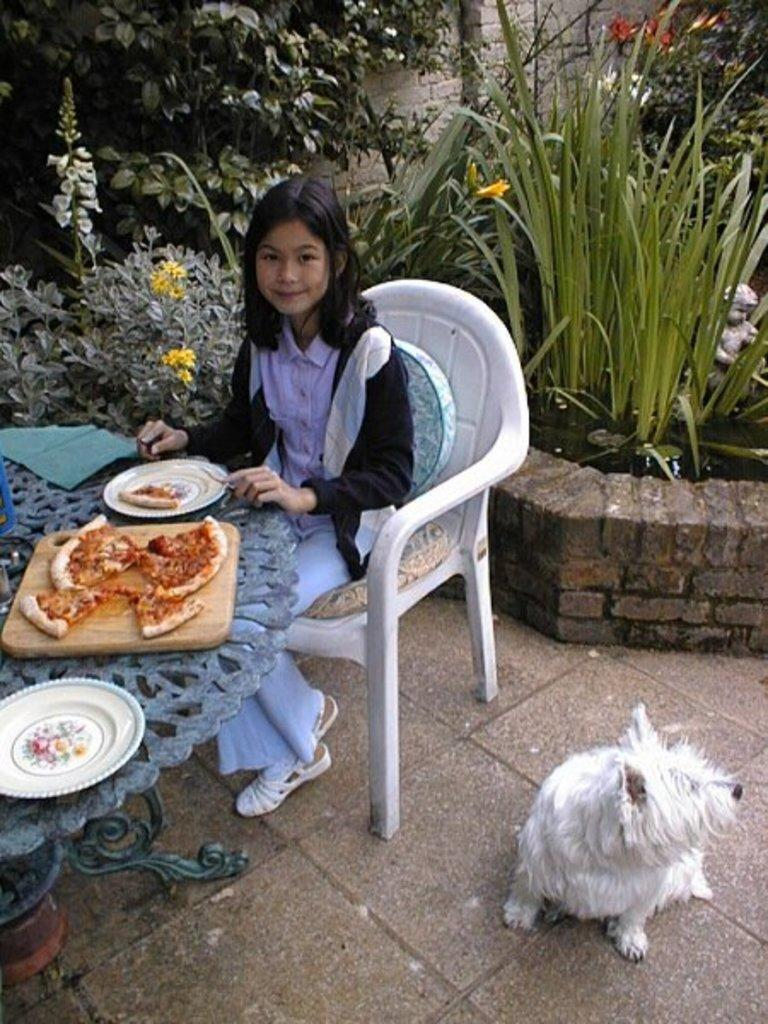What is the woman doing in the image? She is sitting on a chair. What is on the table in the image? There is a plate, pizza, a fork, and tissue on the table. What can be seen in the background of the image? There is a tree, a dog, and flowers in the background of the image. What type of chain is the woman wearing in the image? There is no chain visible on the woman in the image. How many balls are present in the image? There are no balls present in the image. 